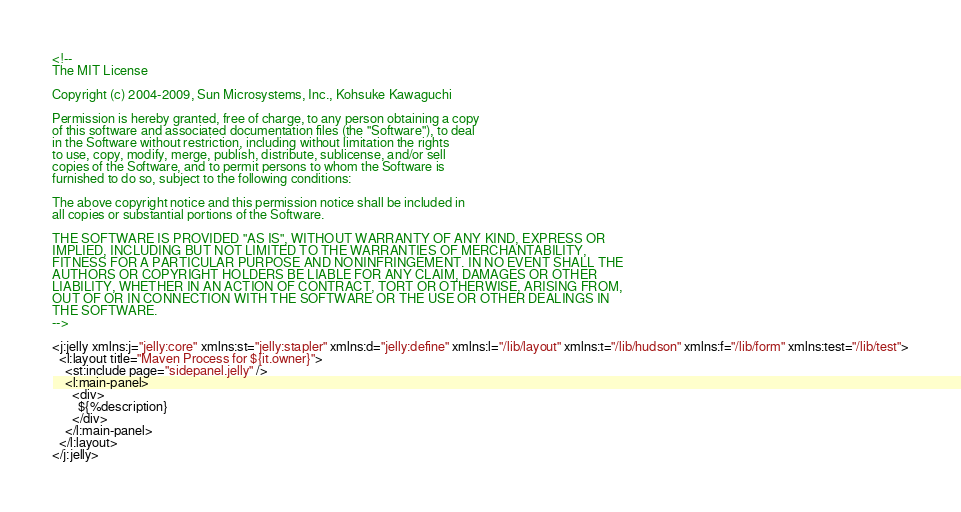Convert code to text. <code><loc_0><loc_0><loc_500><loc_500><_XML_><!--
The MIT License

Copyright (c) 2004-2009, Sun Microsystems, Inc., Kohsuke Kawaguchi

Permission is hereby granted, free of charge, to any person obtaining a copy
of this software and associated documentation files (the "Software"), to deal
in the Software without restriction, including without limitation the rights
to use, copy, modify, merge, publish, distribute, sublicense, and/or sell
copies of the Software, and to permit persons to whom the Software is
furnished to do so, subject to the following conditions:

The above copyright notice and this permission notice shall be included in
all copies or substantial portions of the Software.

THE SOFTWARE IS PROVIDED "AS IS", WITHOUT WARRANTY OF ANY KIND, EXPRESS OR
IMPLIED, INCLUDING BUT NOT LIMITED TO THE WARRANTIES OF MERCHANTABILITY,
FITNESS FOR A PARTICULAR PURPOSE AND NONINFRINGEMENT. IN NO EVENT SHALL THE
AUTHORS OR COPYRIGHT HOLDERS BE LIABLE FOR ANY CLAIM, DAMAGES OR OTHER
LIABILITY, WHETHER IN AN ACTION OF CONTRACT, TORT OR OTHERWISE, ARISING FROM,
OUT OF OR IN CONNECTION WITH THE SOFTWARE OR THE USE OR OTHER DEALINGS IN
THE SOFTWARE.
-->

<j:jelly xmlns:j="jelly:core" xmlns:st="jelly:stapler" xmlns:d="jelly:define" xmlns:l="/lib/layout" xmlns:t="/lib/hudson" xmlns:f="/lib/form" xmlns:test="/lib/test">
  <l:layout title="Maven Process for ${it.owner}">
    <st:include page="sidepanel.jelly" />
    <l:main-panel>
      <div>
        ${%description}
      </div>
    </l:main-panel>
  </l:layout>
</j:jelly></code> 